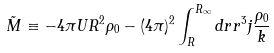Convert formula to latex. <formula><loc_0><loc_0><loc_500><loc_500>\tilde { M } \equiv - 4 \pi U R ^ { 2 } \rho _ { 0 } - ( 4 \pi ) ^ { 2 } \int _ { R } ^ { R _ { \infty } } d r r ^ { 3 } j \frac { \rho _ { 0 } } { k }</formula> 